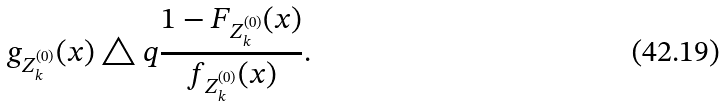Convert formula to latex. <formula><loc_0><loc_0><loc_500><loc_500>g _ { Z _ { k } ^ { ( 0 ) } } ( x ) \triangle q \frac { 1 - F _ { Z _ { k } ^ { ( 0 ) } } ( x ) } { f _ { Z _ { k } ^ { ( 0 ) } } ( x ) } .</formula> 